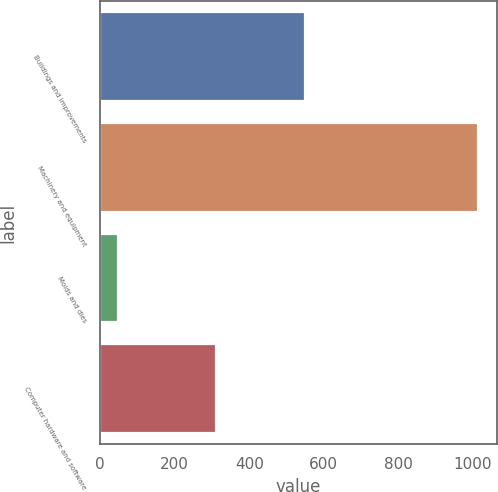Convert chart. <chart><loc_0><loc_0><loc_500><loc_500><bar_chart><fcel>Buildings and improvements<fcel>Machinery and equipment<fcel>Molds and dies<fcel>Computer hardware and software<nl><fcel>550<fcel>1015<fcel>47<fcel>310<nl></chart> 